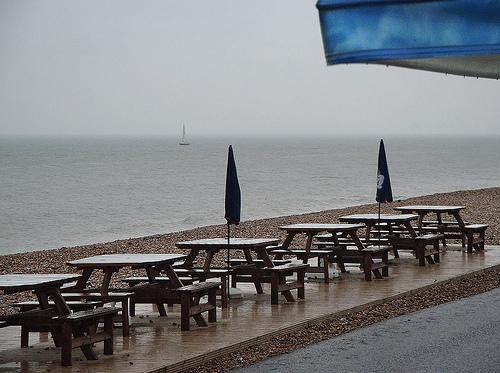Question: how many umbrellas are in the picture?
Choices:
A. 4.
B. 2.
C. 5.
D. 6.
Answer with the letter. Answer: B Question: how many tables are in this picture?
Choices:
A. 4.
B. 6.
C. 5.
D. 8.
Answer with the letter. Answer: B Question: where was this photograph taken?
Choices:
A. At the beach.
B. Mountain.
C. Kitchen.
D. River.
Answer with the letter. Answer: A Question: what kind of boat is visible in the background?
Choices:
A. Yacht.
B. Sailboat.
C. Canoe.
D. Kayak.
Answer with the letter. Answer: B Question: what is the weather like in this picture?
Choices:
A. Rainy.
B. Cloudy.
C. Sunny.
D. Hot.
Answer with the letter. Answer: B 